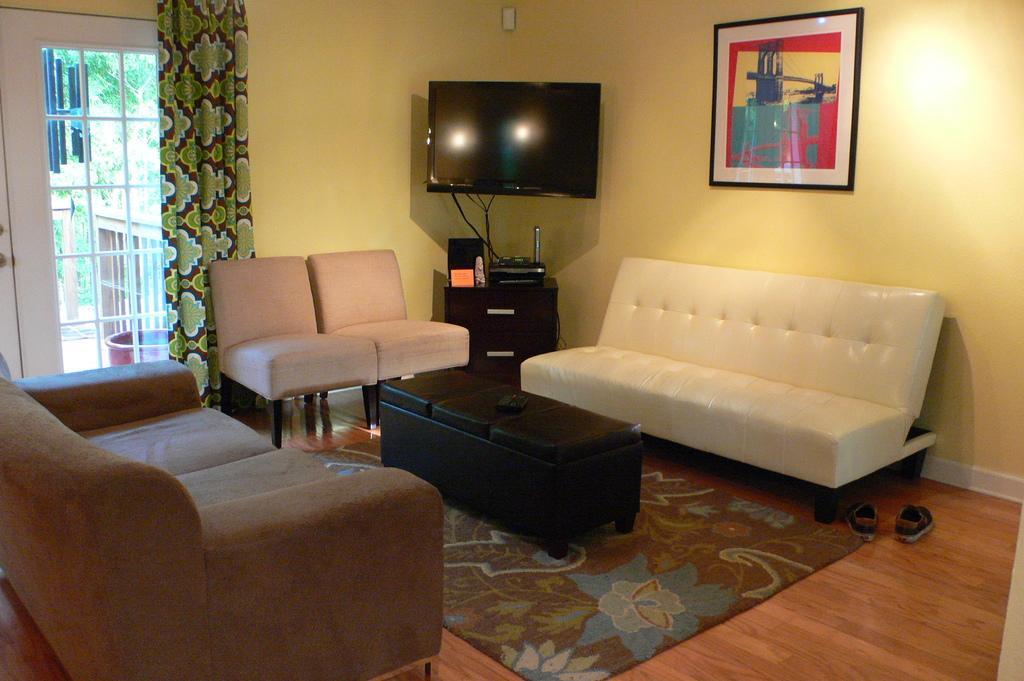How would you summarize this image in a sentence or two? Here in this picture we can see a couch and here we can see a sofa and here we can see a couple of chairs, here we can see a television and at the wall we can see a portrait and at the left side we can see a door with curtain to it , at the bottom right side we can see shoes 